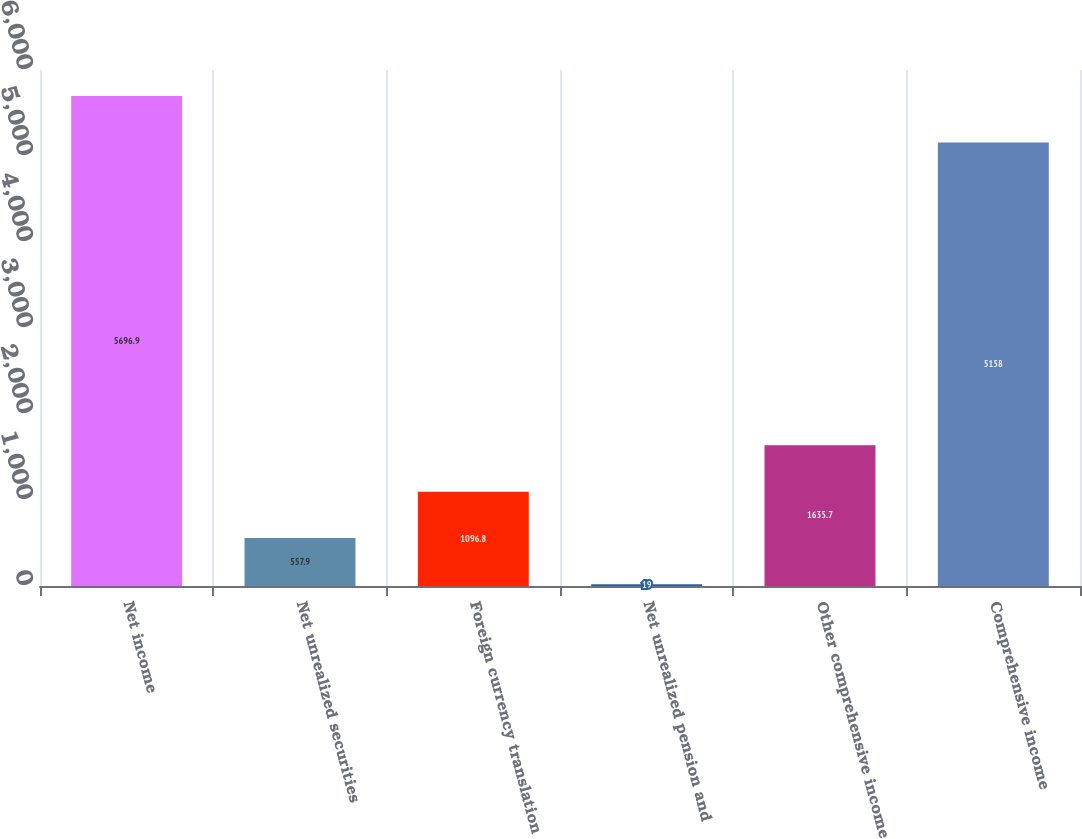Convert chart to OTSL. <chart><loc_0><loc_0><loc_500><loc_500><bar_chart><fcel>Net income<fcel>Net unrealized securities<fcel>Foreign currency translation<fcel>Net unrealized pension and<fcel>Other comprehensive income<fcel>Comprehensive income<nl><fcel>5696.9<fcel>557.9<fcel>1096.8<fcel>19<fcel>1635.7<fcel>5158<nl></chart> 